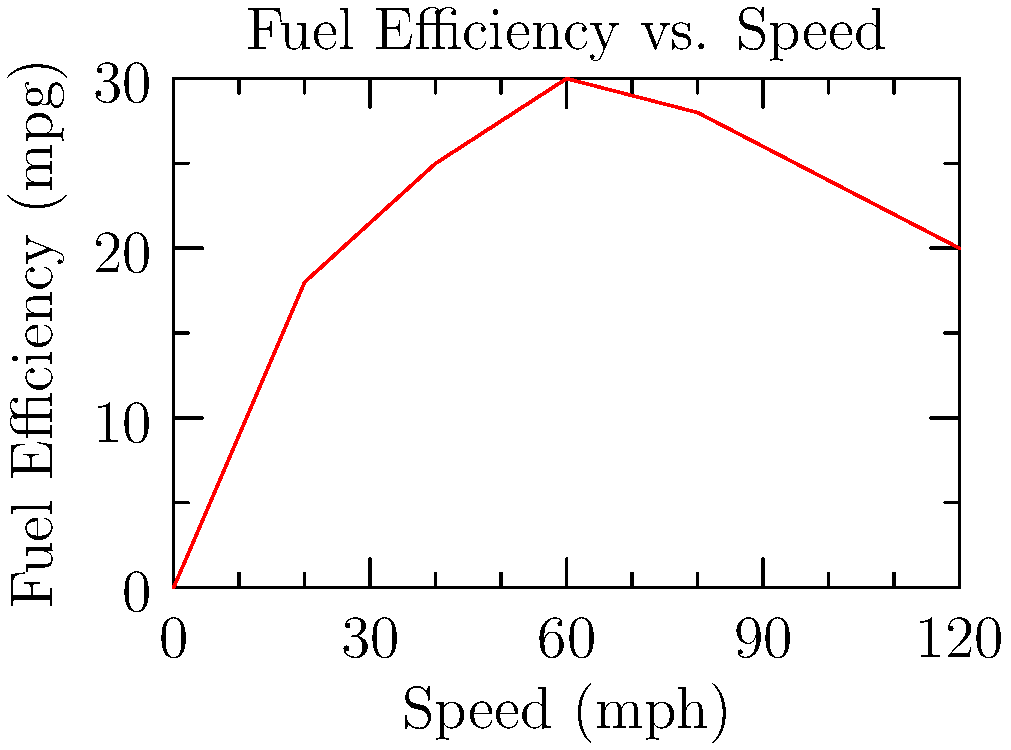As you're refueling your family car at the premium gas station, you notice a chart similar to the one above displayed on the pump. What speed should you maintain on your upcoming road trip to maximize fuel efficiency and minimize stops for refueling? To determine the optimal speed for maximum fuel efficiency:

1. Analyze the graph: The x-axis represents speed in mph, and the y-axis represents fuel efficiency in mpg.

2. Identify the peak: The highest point on the curve indicates maximum fuel efficiency.

3. Locate the corresponding speed: The peak occurs at approximately 60 mph.

4. Interpret the results: At 60 mph, the fuel efficiency is about 30 mpg, which is the highest point on the curve.

5. Consider practical implications: Maintaining this speed on highways is generally safe and legal, making it a realistic choice for a family road trip.

6. Understand the trade-offs: Speeds lower or higher than 60 mph will result in decreased fuel efficiency, requiring more frequent refueling stops.
Answer: 60 mph 